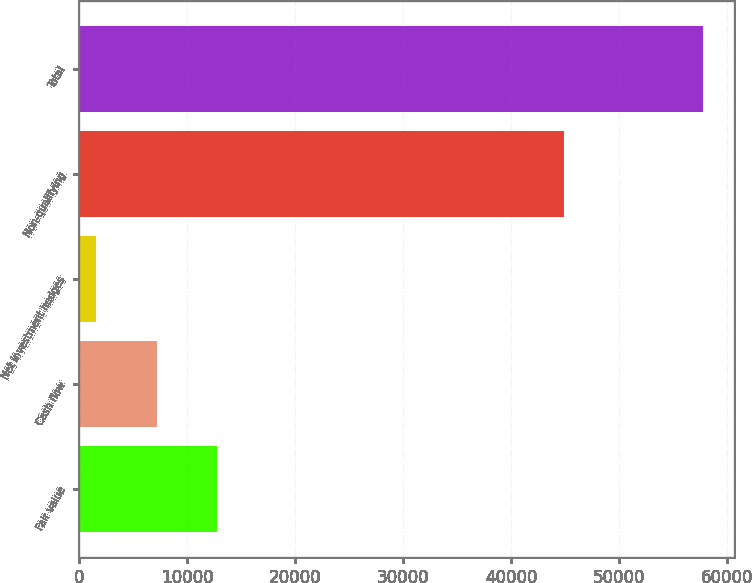<chart> <loc_0><loc_0><loc_500><loc_500><bar_chart><fcel>Fair value<fcel>Cash flow<fcel>Net investment hedges<fcel>Non-qualifying<fcel>Total<nl><fcel>12780.6<fcel>7159.3<fcel>1538<fcel>44865<fcel>57751<nl></chart> 